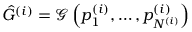<formula> <loc_0><loc_0><loc_500><loc_500>\hat { G } ^ { ( i ) } = \mathcal { G } \left ( p _ { 1 } ^ { ( i ) } , \dots , p _ { N ^ { ( i ) } } ^ { ( i ) } \right )</formula> 